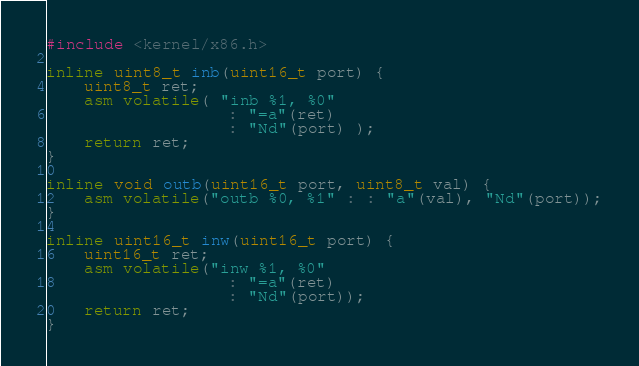<code> <loc_0><loc_0><loc_500><loc_500><_C_>#include <kernel/x86.h>

inline uint8_t inb(uint16_t port) {
    uint8_t ret;
    asm volatile( "inb %1, %0"
                   : "=a"(ret)
                   : "Nd"(port) );
    return ret;
}

inline void outb(uint16_t port, uint8_t val) {
    asm volatile("outb %0, %1" : : "a"(val), "Nd"(port));
}

inline uint16_t inw(uint16_t port) {
    uint16_t ret;
    asm volatile("inw %1, %0"
                   : "=a"(ret)
                   : "Nd"(port));
    return ret;
}
</code> 